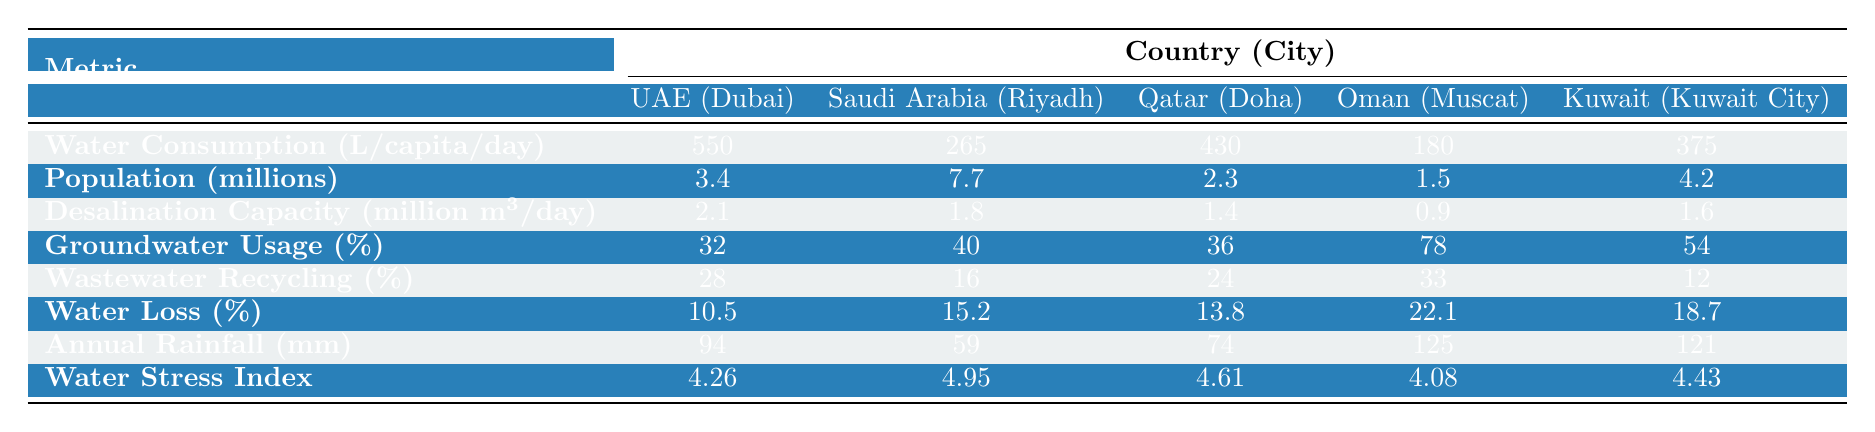What is the water consumption per capita in Dubai? The water consumption per capita for Dubai is stated directly in the table as 550 liters per person per day.
Answer: 550 liters per person per day Which city has the highest population? The table lists the populations for each city. Riyadh has the highest population at 7.7 million.
Answer: Riyadh What is the desalination capacity of Muscat? According to the table, the desalination capacity for Muscat is 0.9 million cubic meters per day.
Answer: 0.9 million cubic meters per day What percentage of water usage in Oman comes from groundwater? The table shows that Oman has a groundwater usage percentage of 78%.
Answer: 78% Which city has the lowest wastewater recycling percentage? The table indicates that Kuwait City has the lowest wastewater recycling percentage at 12%.
Answer: 12% What is the average annual rainfall for the cities listed? The annual rainfall data are summed: 94 + 59 + 74 + 125 + 121 = 473 mm. There are 5 cities, so the average is 473/5 = 94.6 mm.
Answer: 94.6 mm Do more than half of the water consumption in Dubai come from desalination? Desalination capacity in Dubai is 2.1 million cubic meters per day. Although it does play a significant role, the table does not provide a direct breakdown to confirm if it exceeds half. Therefore, the answer is no, based on the given data context.
Answer: No Which city has the highest water stress index? Consulting the table, Riyadh has the highest water stress index at 4.95.
Answer: Riyadh What is the difference in water loss percentage between Riyadh and Oman? The water loss percentage for Riyadh is 15.2% and for Oman is 22.1%. The difference is 22.1 - 15.2 = 6.9%.
Answer: 6.9% Is the water consumption per capita in Doha higher than in Kuwait City? The water consumption in Doha is 430 liters per capita, while in Kuwait City it is 375 liters. Since 430 is greater than 375, the answer is yes.
Answer: Yes 